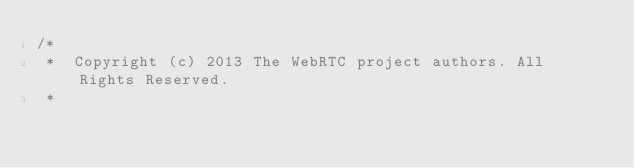<code> <loc_0><loc_0><loc_500><loc_500><_ObjectiveC_>/*
 *  Copyright (c) 2013 The WebRTC project authors. All Rights Reserved.
 *</code> 